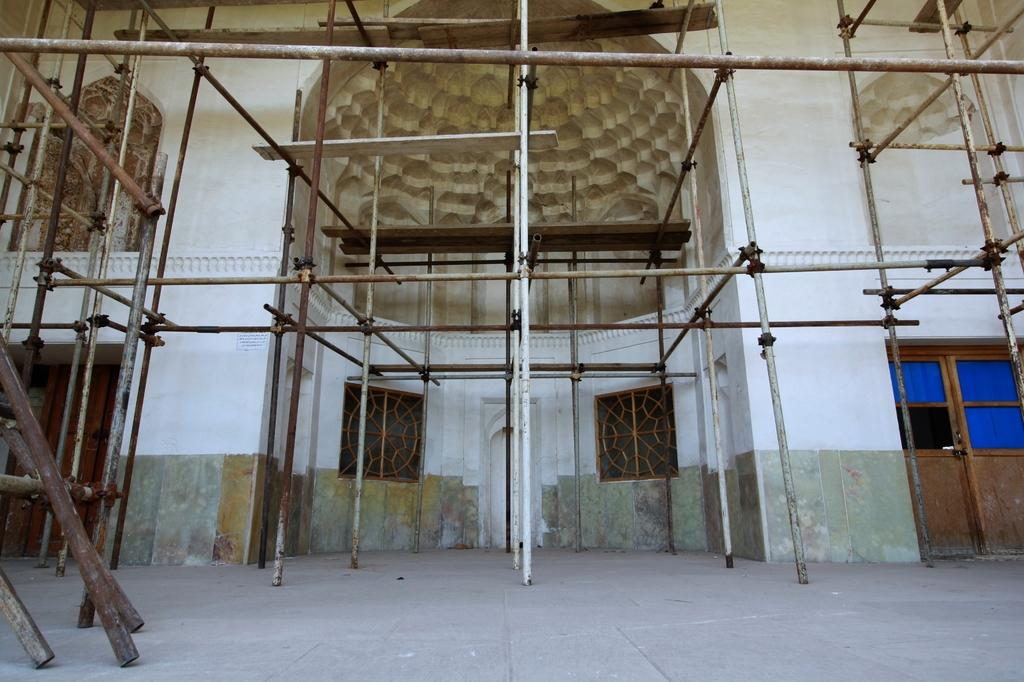What is located in the center of the image? There are poles in the center of the image. What can be seen in the background of the image? There is a building in the background of the image. What features are present on the building? There are doors and windows on the building. What type of shape is being offered by the building in the image? There is no indication in the image that the building is offering any shape. 